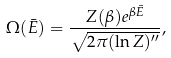<formula> <loc_0><loc_0><loc_500><loc_500>\Omega ( \bar { E } ) = \frac { Z ( \beta ) e ^ { \beta \bar { E } } } { \sqrt { 2 \pi ( \ln Z ) ^ { \prime \prime } } } ,</formula> 